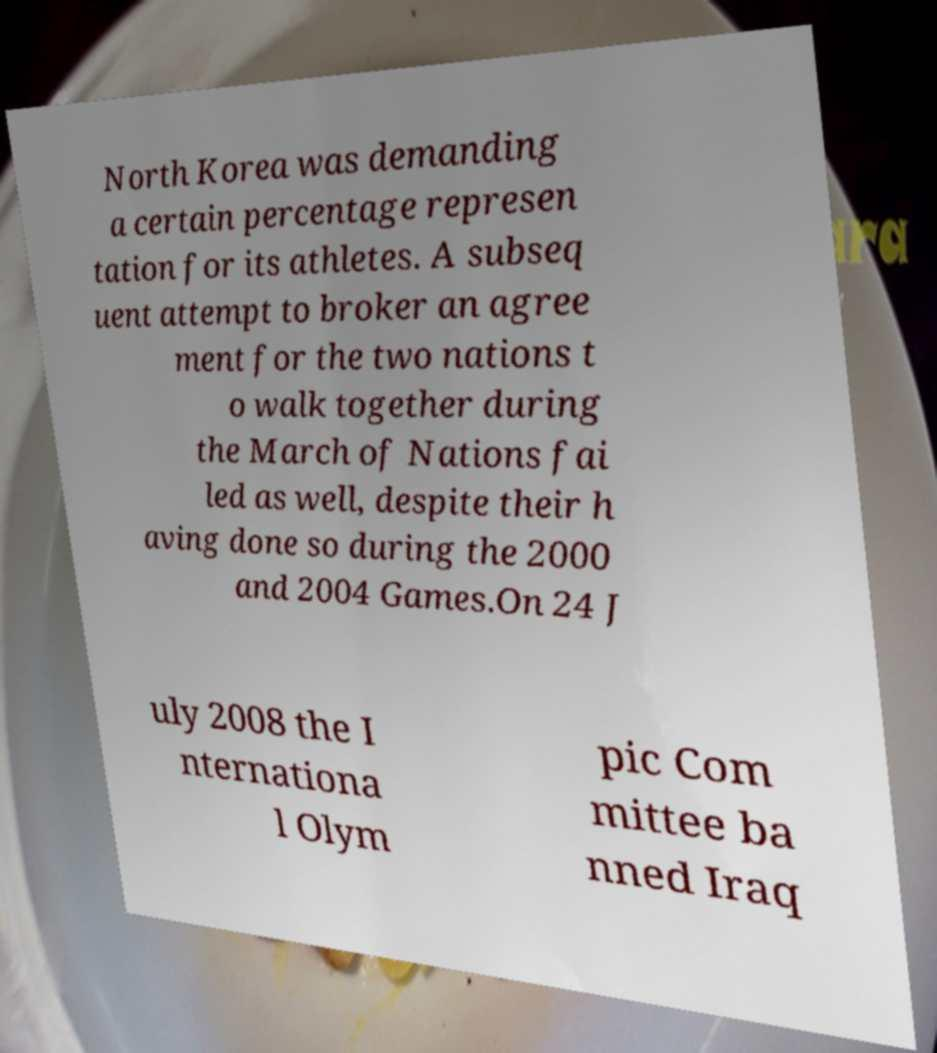For documentation purposes, I need the text within this image transcribed. Could you provide that? North Korea was demanding a certain percentage represen tation for its athletes. A subseq uent attempt to broker an agree ment for the two nations t o walk together during the March of Nations fai led as well, despite their h aving done so during the 2000 and 2004 Games.On 24 J uly 2008 the I nternationa l Olym pic Com mittee ba nned Iraq 